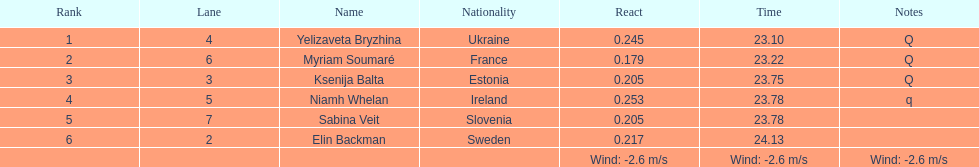Whose time is more than. 24.00? Elin Backman. 